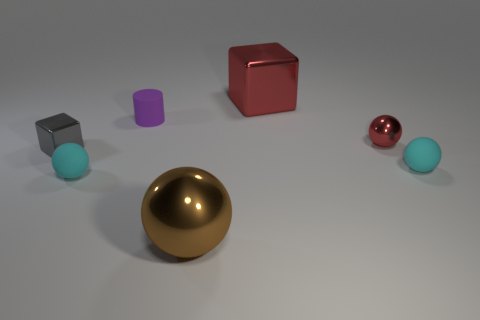Is the color of the large cube the same as the small shiny ball?
Your answer should be very brief. Yes. Are there any other things that have the same shape as the tiny purple matte object?
Give a very brief answer. No. What is the shape of the purple matte object?
Provide a short and direct response. Cylinder. What number of tiny things are cyan matte balls or gray objects?
Keep it short and to the point. 3. There is another metal thing that is the same shape as the small gray thing; what is its size?
Your response must be concise. Large. What number of objects are both behind the brown thing and on the right side of the small gray thing?
Give a very brief answer. 5. There is a large brown metallic thing; is it the same shape as the cyan rubber thing that is to the right of the small red sphere?
Offer a very short reply. Yes. Are there more big shiny cubes on the left side of the cylinder than brown metallic spheres?
Keep it short and to the point. No. Are there fewer cylinders that are on the left side of the tiny gray metallic block than blue metallic cylinders?
Provide a succinct answer. No. How many tiny metal things are the same color as the tiny cylinder?
Your answer should be compact. 0. 